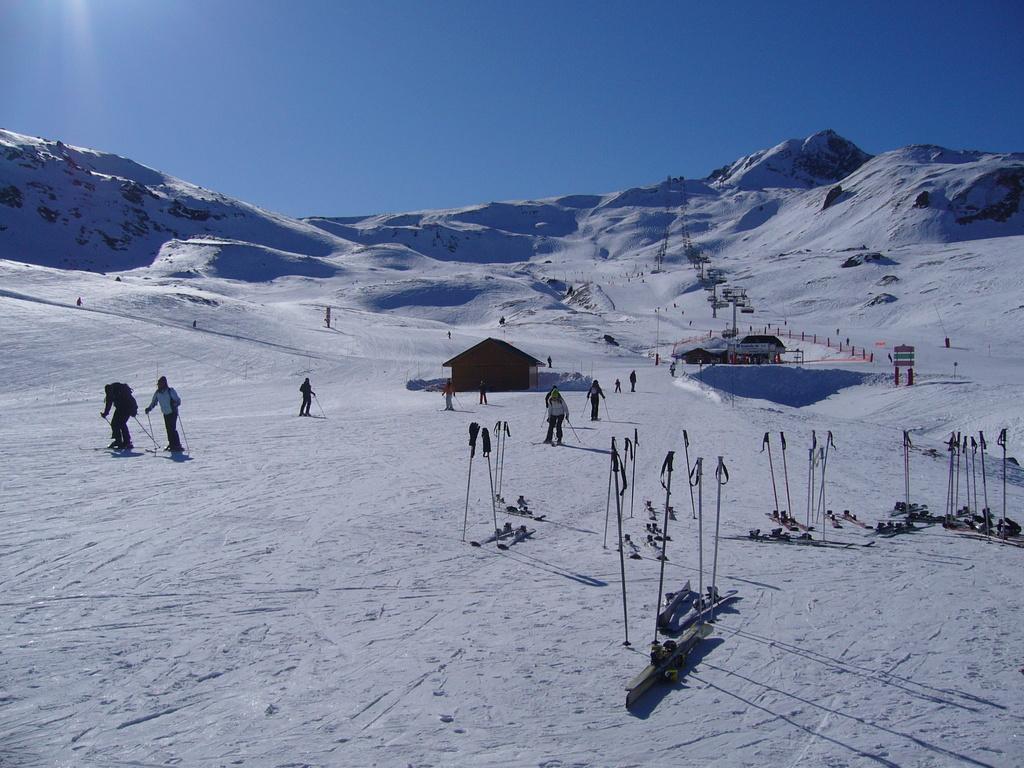Can you describe this image briefly? In this picture we can see snow at the bottom, there are some people skiing on ski boards, on the right side we can see sticks and ski boards, there is a house in the middle, in the background we can see a board, there is the sky at the top of the picture. 